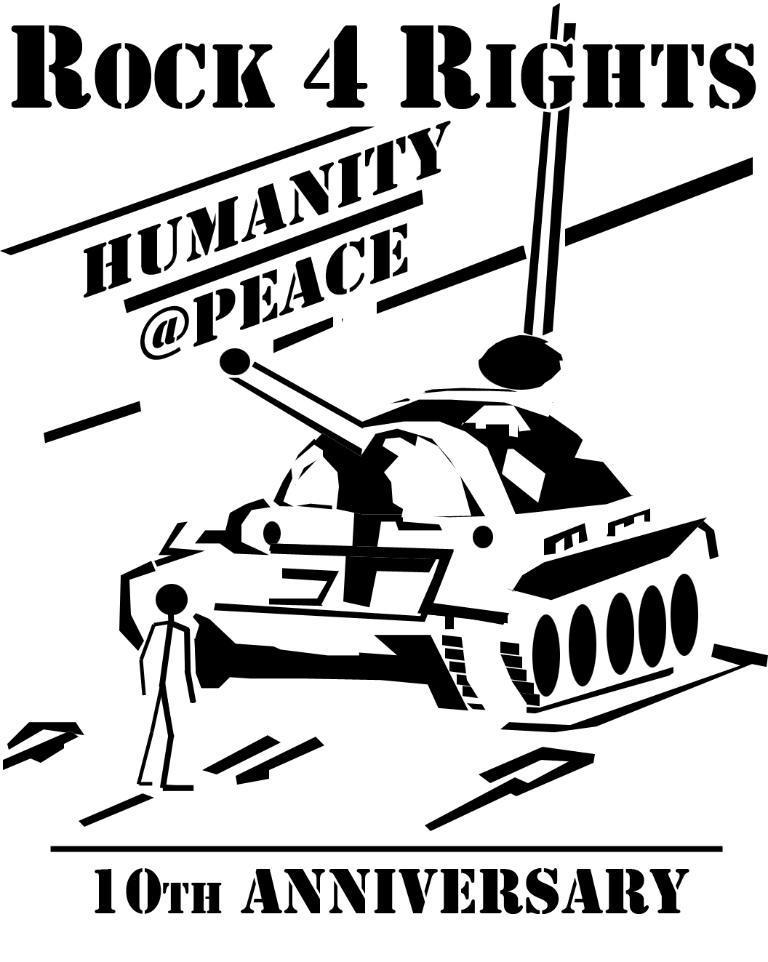Could you give a brief overview of what you see in this image? In this image I can see the poster. In the poster I can see the military tank, person and something is written on it. 